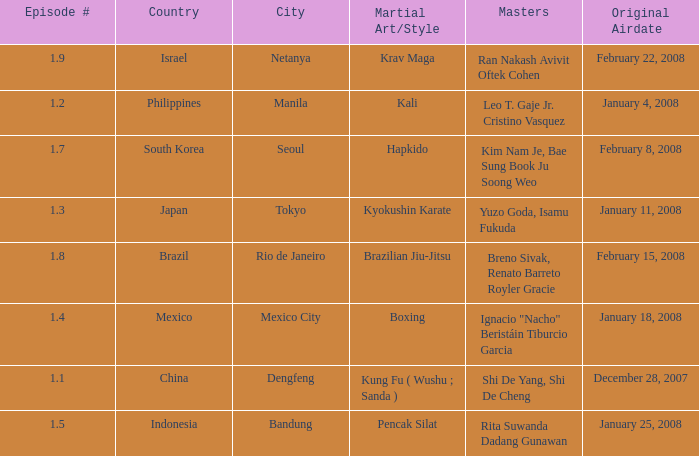In which country is the city of Netanya? Israel. Would you be able to parse every entry in this table? {'header': ['Episode #', 'Country', 'City', 'Martial Art/Style', 'Masters', 'Original Airdate'], 'rows': [['1.9', 'Israel', 'Netanya', 'Krav Maga', 'Ran Nakash Avivit Oftek Cohen', 'February 22, 2008'], ['1.2', 'Philippines', 'Manila', 'Kali', 'Leo T. Gaje Jr. Cristino Vasquez', 'January 4, 2008'], ['1.7', 'South Korea', 'Seoul', 'Hapkido', 'Kim Nam Je, Bae Sung Book Ju Soong Weo', 'February 8, 2008'], ['1.3', 'Japan', 'Tokyo', 'Kyokushin Karate', 'Yuzo Goda, Isamu Fukuda', 'January 11, 2008'], ['1.8', 'Brazil', 'Rio de Janeiro', 'Brazilian Jiu-Jitsu', 'Breno Sivak, Renato Barreto Royler Gracie', 'February 15, 2008'], ['1.4', 'Mexico', 'Mexico City', 'Boxing', 'Ignacio "Nacho" Beristáin Tiburcio Garcia', 'January 18, 2008'], ['1.1', 'China', 'Dengfeng', 'Kung Fu ( Wushu ; Sanda )', 'Shi De Yang, Shi De Cheng', 'December 28, 2007'], ['1.5', 'Indonesia', 'Bandung', 'Pencak Silat', 'Rita Suwanda Dadang Gunawan', 'January 25, 2008']]} 